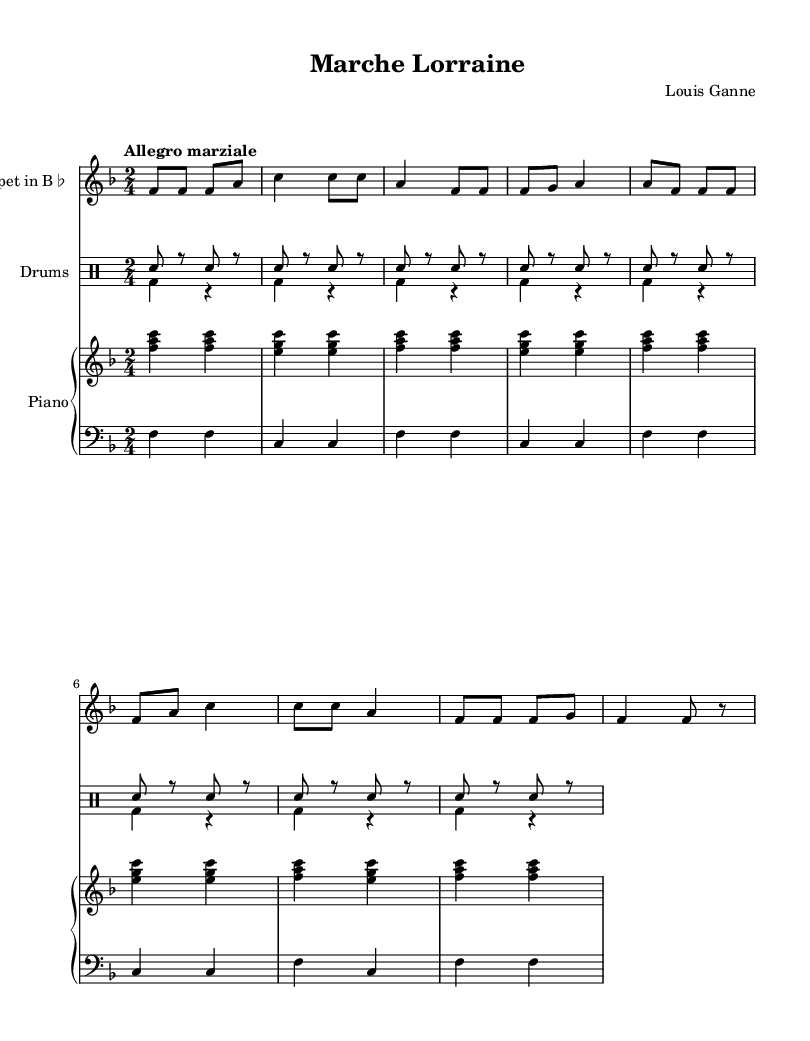What is the key signature of this music? The key signature is F major, which has one flat (B♭). This is indicated at the beginning of the score.
Answer: F major What is the time signature of this music? The time signature is 2/4, which is noted at the beginning of the score. This means there are two beats in each measure and the quarter note gets one beat.
Answer: 2/4 What is the tempo marking for this piece? The tempo marking is "Allegro marziale," which indicates a fast tempo with a martial character, typically associated with marches. This is also noted at the start of the score.
Answer: Allegro marziale How many beats are in each measure? Each measure has two beats, as indicated by the time signature of 2/4. Each beat can be played as a quarter note, or subdivided further into smaller note values.
Answer: 2 What instruments are featured in this score? The instruments featured in this score are Trumpet in B♭, Drums, and Piano. Each instrument is specified at the start of the corresponding staff.
Answer: Trumpet in B♭, Drums, Piano What is the rhythmic pattern for the snare drum? The snare drum part alternates between a snare hit and a rest for a total of eight repetitions, which creates a specific rhythmic feel in 2/4 time. This is represented in the drum part.
Answer: Snare hit and rest Identify a characteristic feature of patriotic anthems reflected in this piece. The piece has a march-like tempo and is composed in a major key, both of which are typical features of patriotic anthems, creating an uplifting and bold sound that often accompanies nationalistic sentiments.
Answer: March-like tempo, Major key 